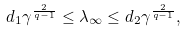<formula> <loc_0><loc_0><loc_500><loc_500>d _ { 1 } \gamma ^ { \frac { 2 } { q - 1 } } \leq \lambda _ { \infty } \leq d _ { 2 } \gamma ^ { \frac { 2 } { q - 1 } } ,</formula> 